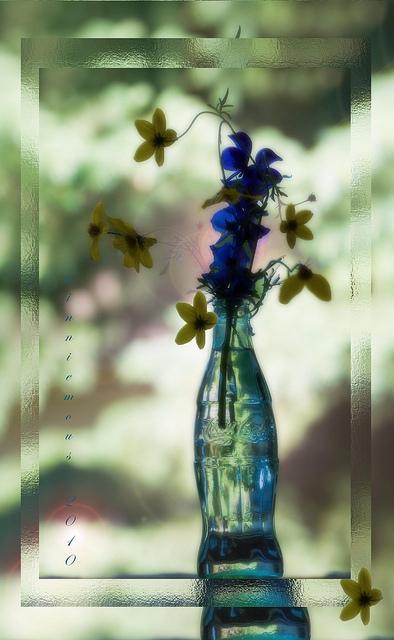Is the bottle opaque?
Be succinct. Yes. Are there at least three varieties of blue here?
Keep it brief. Yes. What kind of vase is this?
Quick response, please. Coke bottle. Is there a reflection in this picture?
Quick response, please. Yes. 